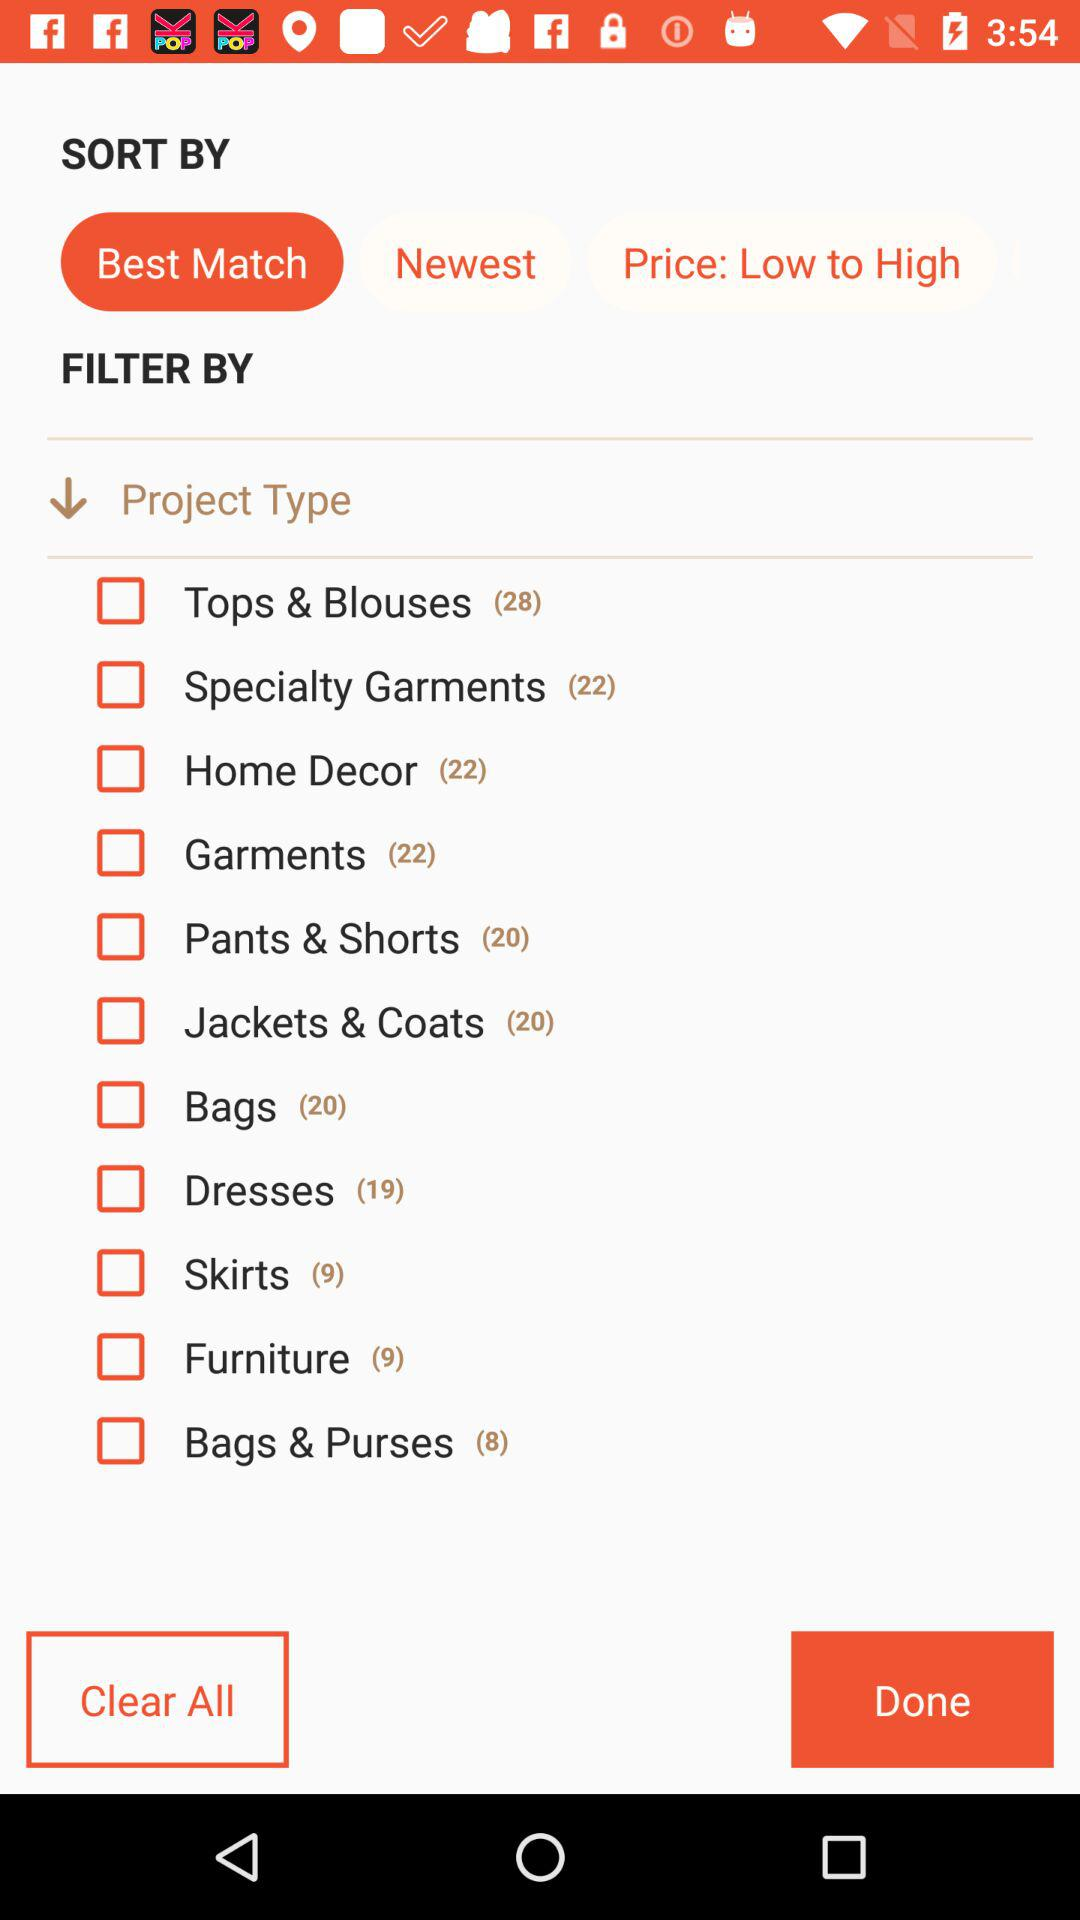How many varieties are available for home decor? There are 22 varieties available for home decor. 